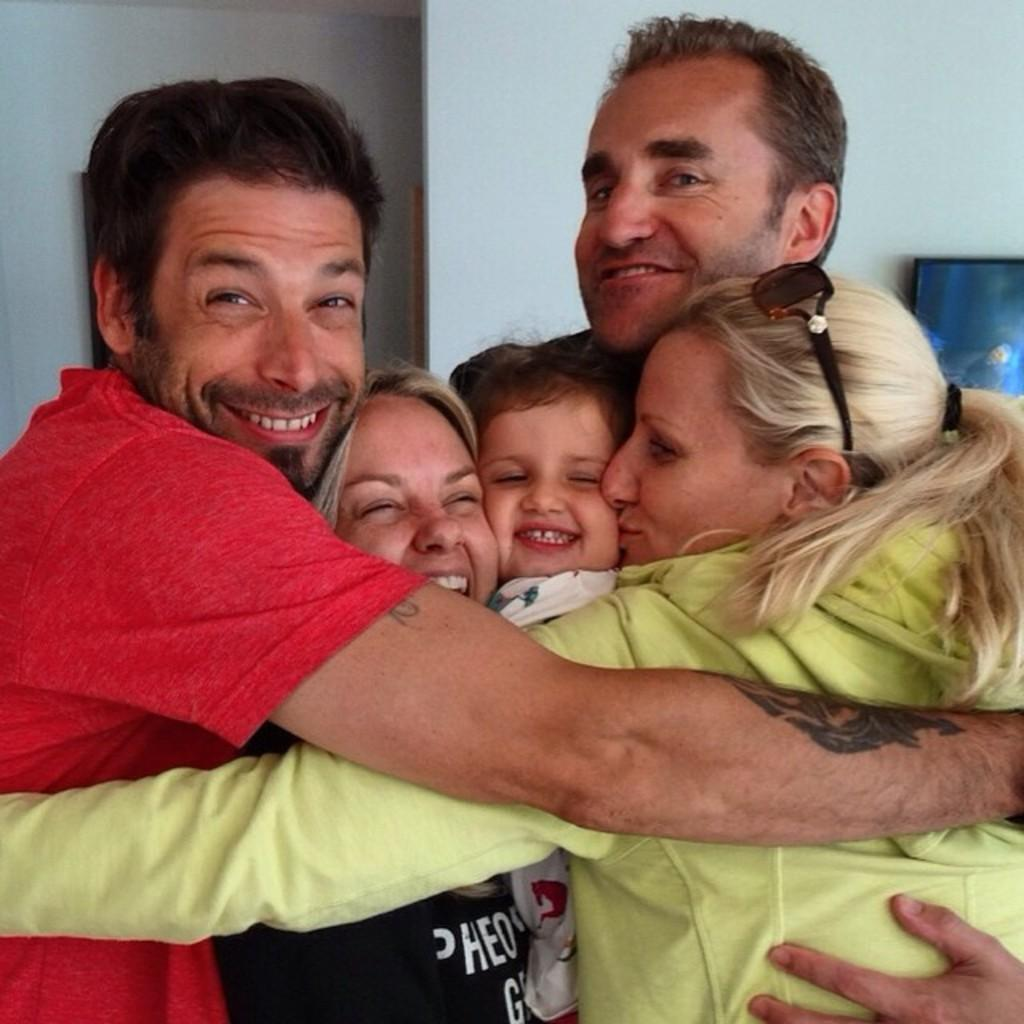What types of people can be seen in the image? There are men, women, and a kid in the image. What is the general mood of the people in the image? The people in the image are smiling, which suggests a positive mood. What can be seen on the wall in the background of the image? There is a frame placed on the wall in the background of the image. What arithmetic problem is the kid solving in the image? There is no arithmetic problem visible in the image, as the focus is on the people and their expressions. Can you tell me how many lizards are present in the image? There are no lizards present in the image. 